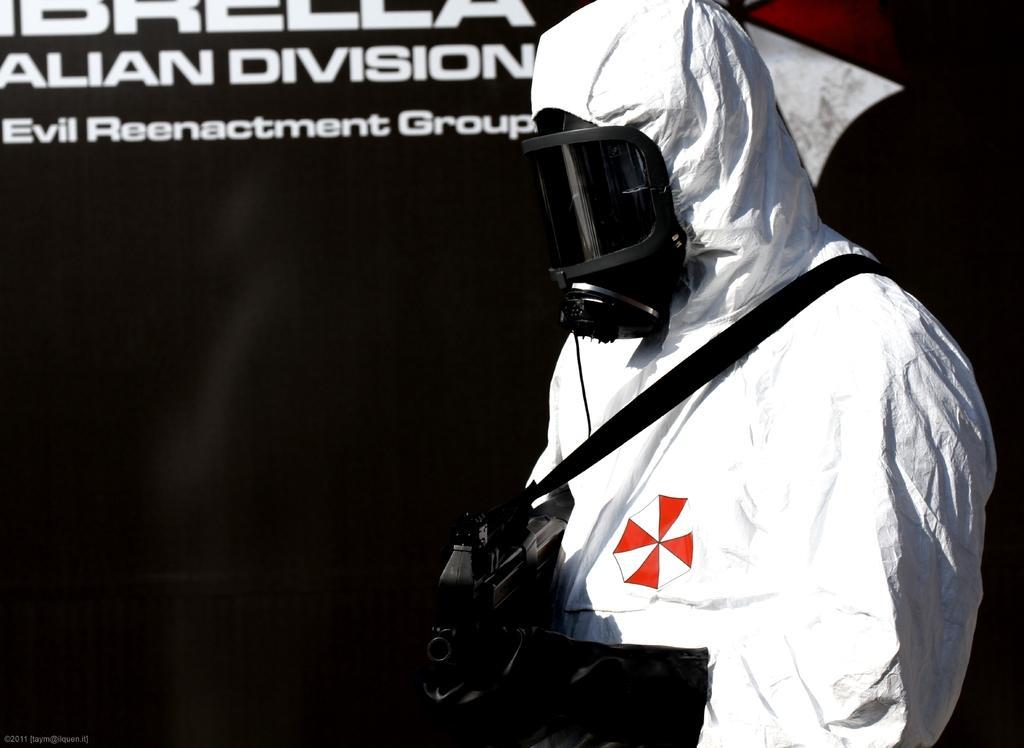In one or two sentences, can you explain what this image depicts? In this image we can see a person with a mask and holding something in the hand. In the back there is a wall with text. 